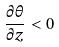<formula> <loc_0><loc_0><loc_500><loc_500>\frac { \partial \theta } { \partial z } < 0</formula> 